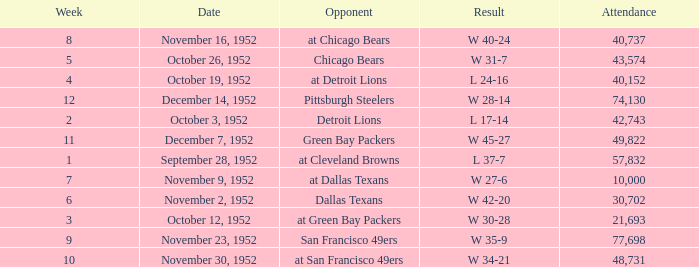When is the last week that has a result of a w 34-21? 10.0. 